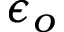<formula> <loc_0><loc_0><loc_500><loc_500>\epsilon _ { o }</formula> 